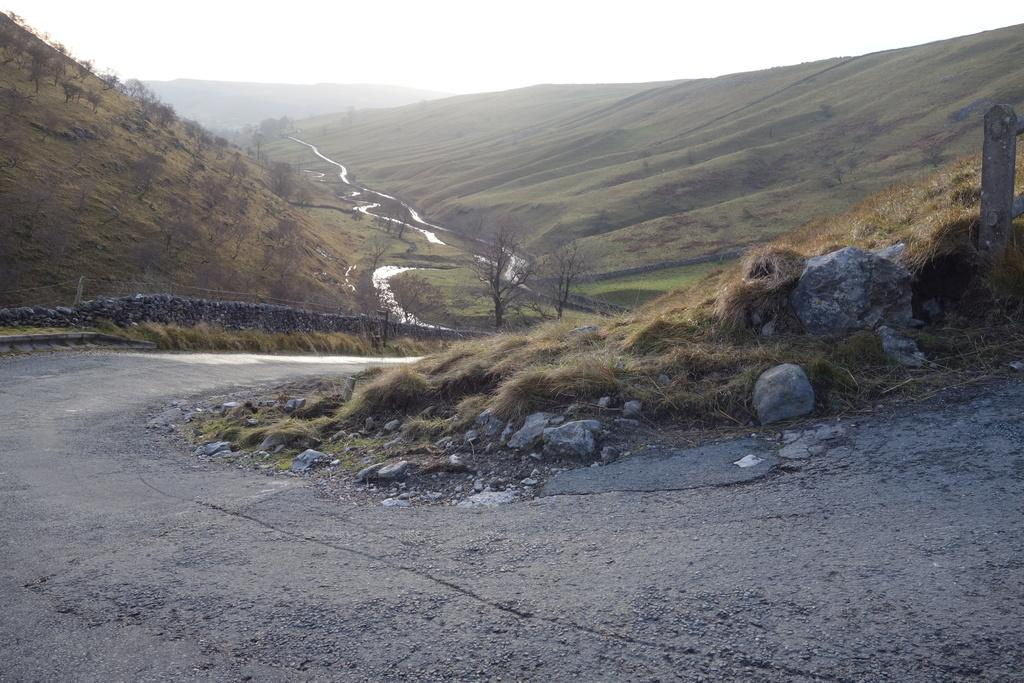What type of natural formation can be seen in the image? There are mountains in the image. What is the appearance of the mountains? The mountains are covered in grass. Are there any trees visible on the mountains? Yes, there are two dry trees on the mountains. What is located at the bottom of the image? There is a road at the bottom of the image. What type of material is used to make the leather jackets worn by the people in the image? There are no people or leather jackets present in the image; it features mountains, grass, trees, and a road. 